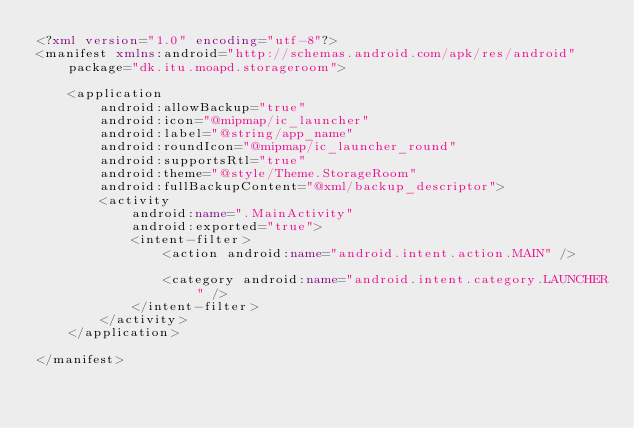Convert code to text. <code><loc_0><loc_0><loc_500><loc_500><_XML_><?xml version="1.0" encoding="utf-8"?>
<manifest xmlns:android="http://schemas.android.com/apk/res/android"
    package="dk.itu.moapd.storageroom">

    <application
        android:allowBackup="true"
        android:icon="@mipmap/ic_launcher"
        android:label="@string/app_name"
        android:roundIcon="@mipmap/ic_launcher_round"
        android:supportsRtl="true"
        android:theme="@style/Theme.StorageRoom"
        android:fullBackupContent="@xml/backup_descriptor">
        <activity
            android:name=".MainActivity"
            android:exported="true">
            <intent-filter>
                <action android:name="android.intent.action.MAIN" />

                <category android:name="android.intent.category.LAUNCHER" />
            </intent-filter>
        </activity>
    </application>

</manifest></code> 